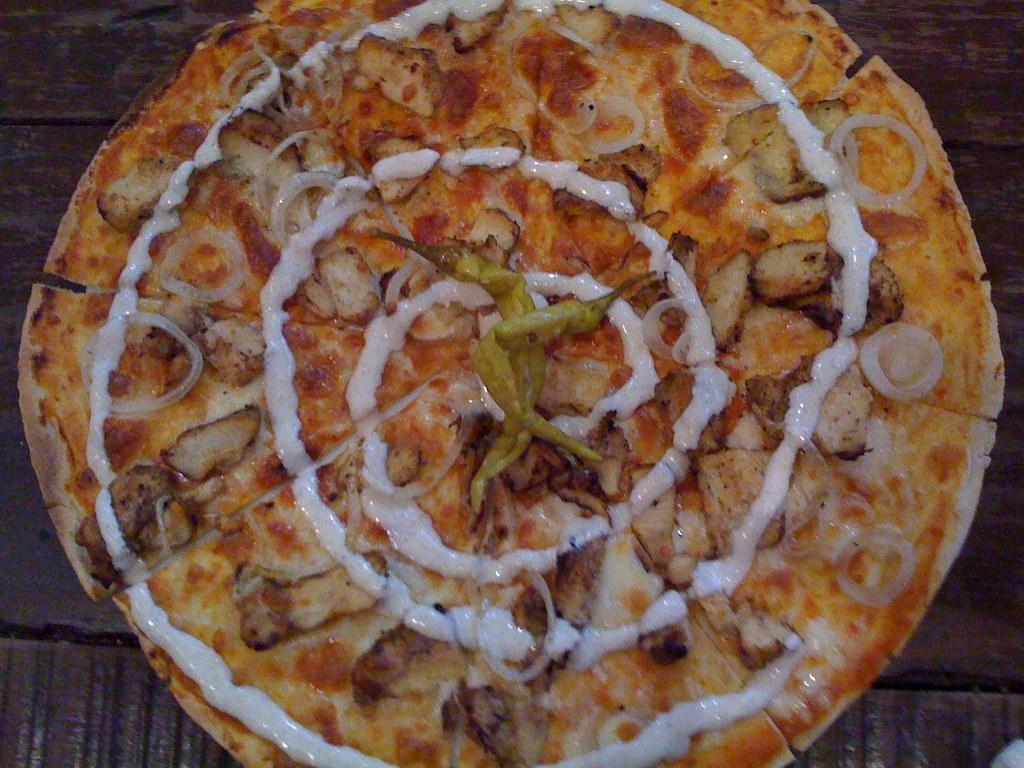Describe this image in one or two sentences. In the image I can see food item on which there are some green chilies and some cream. 